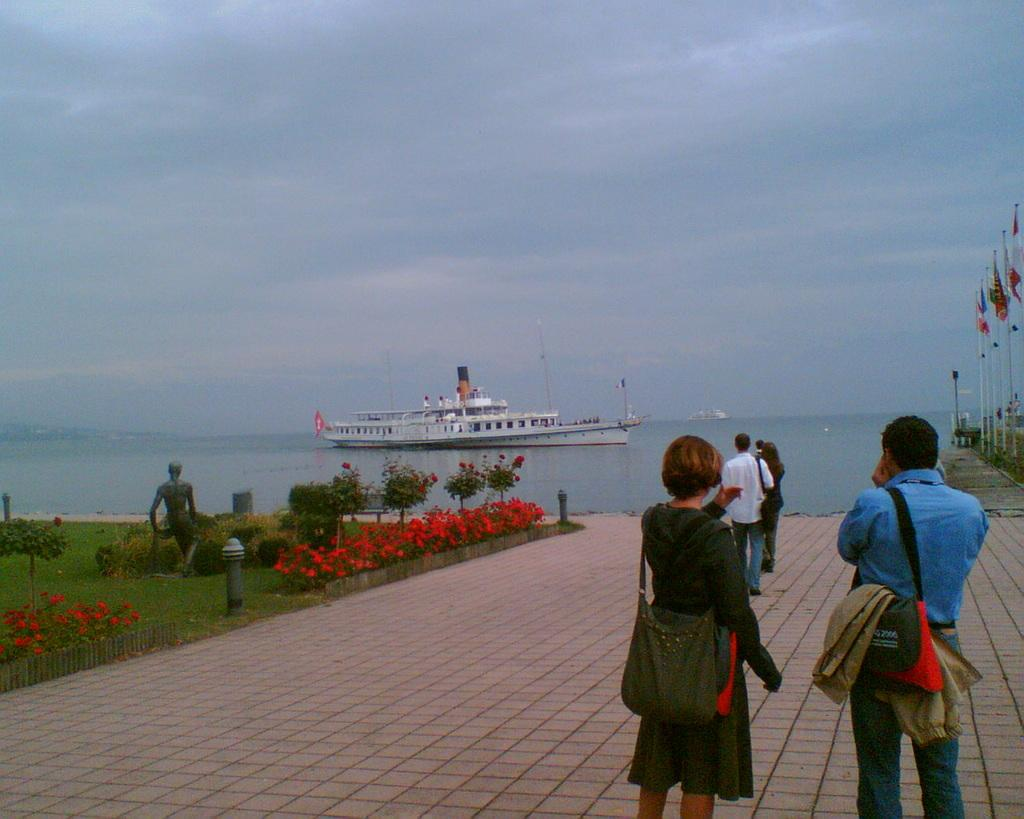What are the people in the image doing? The people in the image are walking on a walkway. What can be seen in the background of the image? There is a ship and an ocean visible in the background of the image. What type of representative is standing near the ship in the image? There is no representative present in the image; it only shows people walking on a walkway and a ship in the background. 